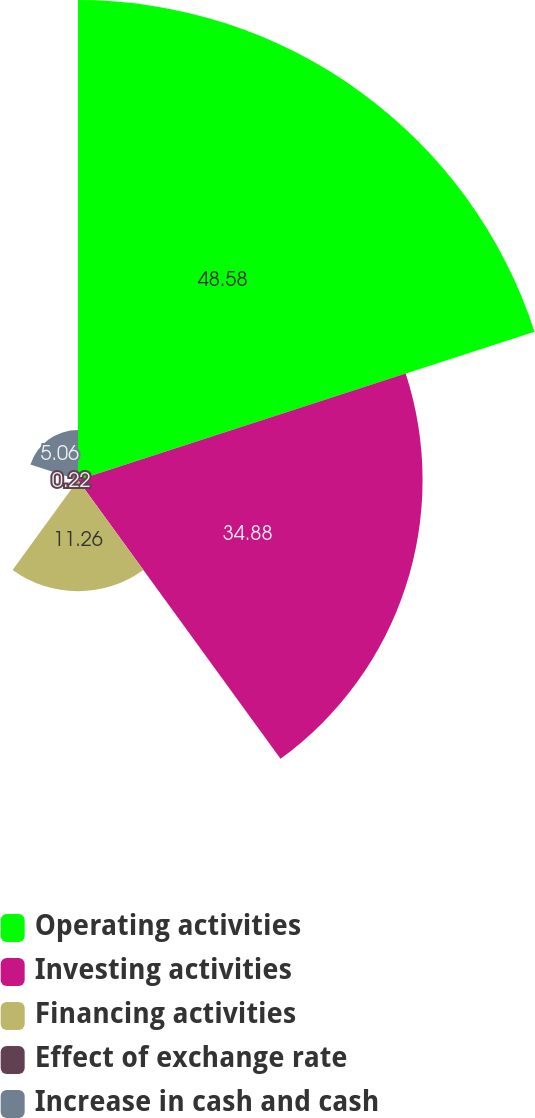<chart> <loc_0><loc_0><loc_500><loc_500><pie_chart><fcel>Operating activities<fcel>Investing activities<fcel>Financing activities<fcel>Effect of exchange rate<fcel>Increase in cash and cash<nl><fcel>48.59%<fcel>34.88%<fcel>11.26%<fcel>0.22%<fcel>5.06%<nl></chart> 